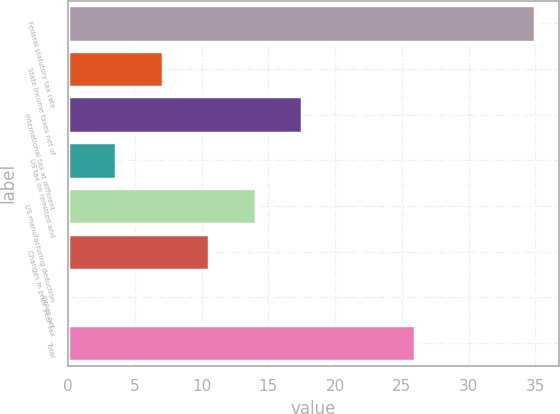Convert chart. <chart><loc_0><loc_0><loc_500><loc_500><bar_chart><fcel>Federal statutory tax rate<fcel>State income taxes net of<fcel>International tax at different<fcel>US tax on remitted and<fcel>US manufacturing deduction<fcel>Changes in prior year tax<fcel>Other net<fcel>Total<nl><fcel>35<fcel>7.08<fcel>17.55<fcel>3.59<fcel>14.06<fcel>10.57<fcel>0.1<fcel>26<nl></chart> 